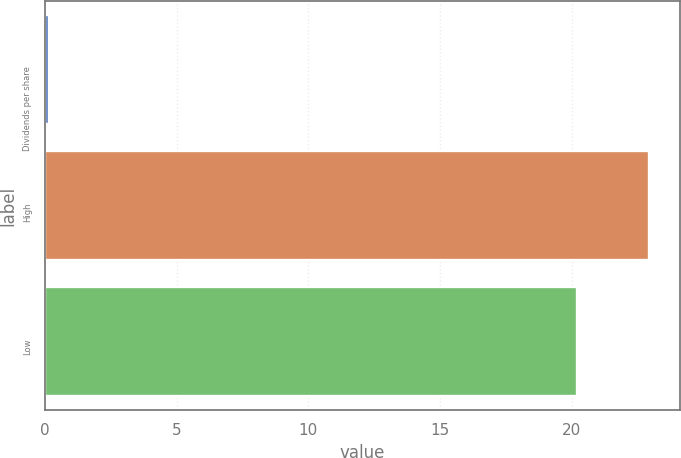<chart> <loc_0><loc_0><loc_500><loc_500><bar_chart><fcel>Dividends per share<fcel>High<fcel>Low<nl><fcel>0.14<fcel>22.94<fcel>20.2<nl></chart> 